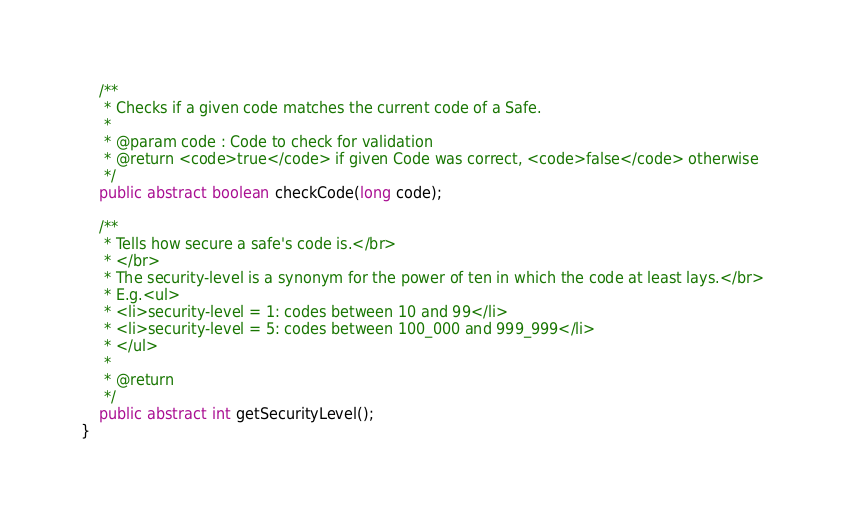<code> <loc_0><loc_0><loc_500><loc_500><_Java_>	/**
	 * Checks if a given code matches the current code of a Safe.
	 * 
	 * @param code : Code to check for validation
	 * @return <code>true</code> if given Code was correct, <code>false</code> otherwise
	 */
	public abstract boolean checkCode(long code);
	
	/**
	 * Tells how secure a safe's code is.</br>
	 * </br>
	 * The security-level is a synonym for the power of ten in which the code at least lays.</br>
	 * E.g.<ul>
	 * <li>security-level = 1: codes between 10 and 99</li>
	 * <li>security-level = 5: codes between 100_000 and 999_999</li>
	 * </ul>
	 * 
	 * @return
	 */
	public abstract int getSecurityLevel();
}
</code> 